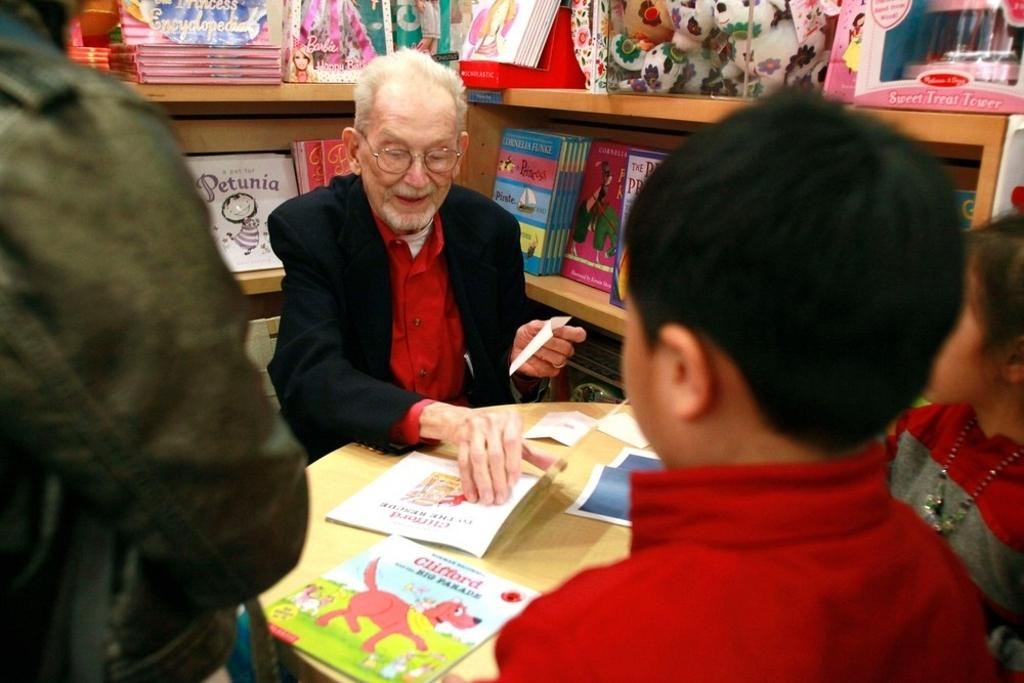How many people are in the image? There are three persons in the image. What is the position of one of the men in the image? One man is sitting. What can be seen on the table in the image? There are papers on the table. What is a man holding in the image? A man is holding a paper. What type of items can be seen in the background of the image? There are books and toys in the background of the image. How are the toys arranged in the image? The toys are in racks in the background of the image. What type of floor can be seen in the image? There is no specific mention of the floor in the image, so we cannot determine its type. Is this image taken in a school setting? The image does not provide any context or clues to suggest that it was taken in a school setting. 